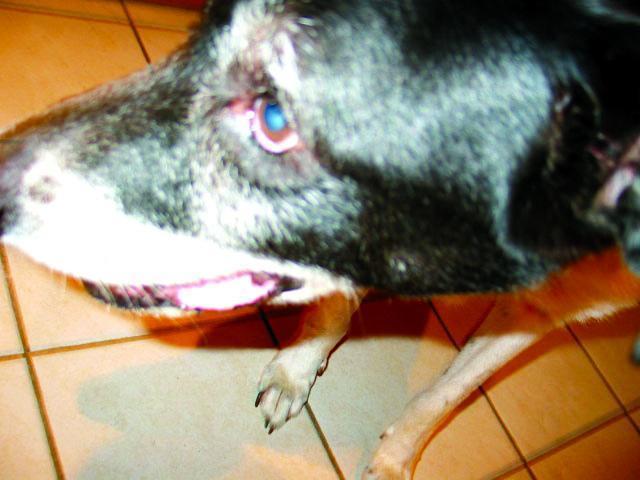How many people are in the yellow cart?
Give a very brief answer. 0. 